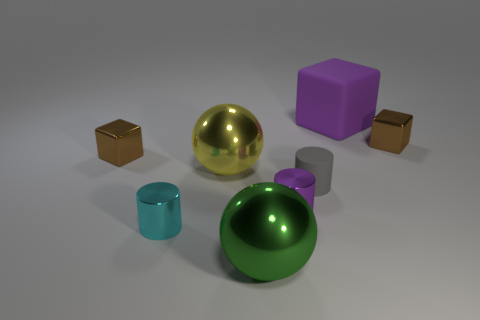Add 1 big objects. How many objects exist? 9 Subtract all cubes. How many objects are left? 5 Add 6 big balls. How many big balls exist? 8 Subtract 1 purple blocks. How many objects are left? 7 Subtract all tiny brown metal cylinders. Subtract all green metallic spheres. How many objects are left? 7 Add 7 small gray objects. How many small gray objects are left? 8 